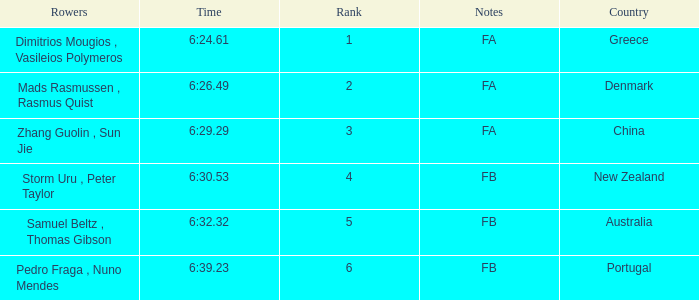What country has a rank smaller than 6, a time of 6:32.32 and notes of FB? Australia. 